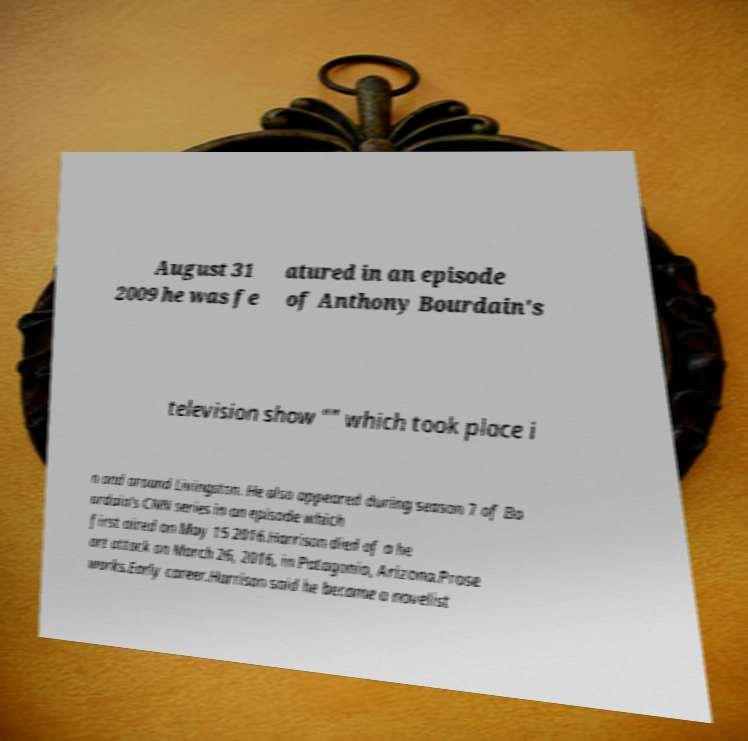Can you accurately transcribe the text from the provided image for me? August 31 2009 he was fe atured in an episode of Anthony Bourdain's television show "" which took place i n and around Livingston. He also appeared during season 7 of Bo urdain's CNN series in an episode which first aired on May 15 2016.Harrison died of a he art attack on March 26, 2016, in Patagonia, Arizona.Prose works.Early career.Harrison said he became a novelist 